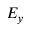<formula> <loc_0><loc_0><loc_500><loc_500>E _ { y }</formula> 